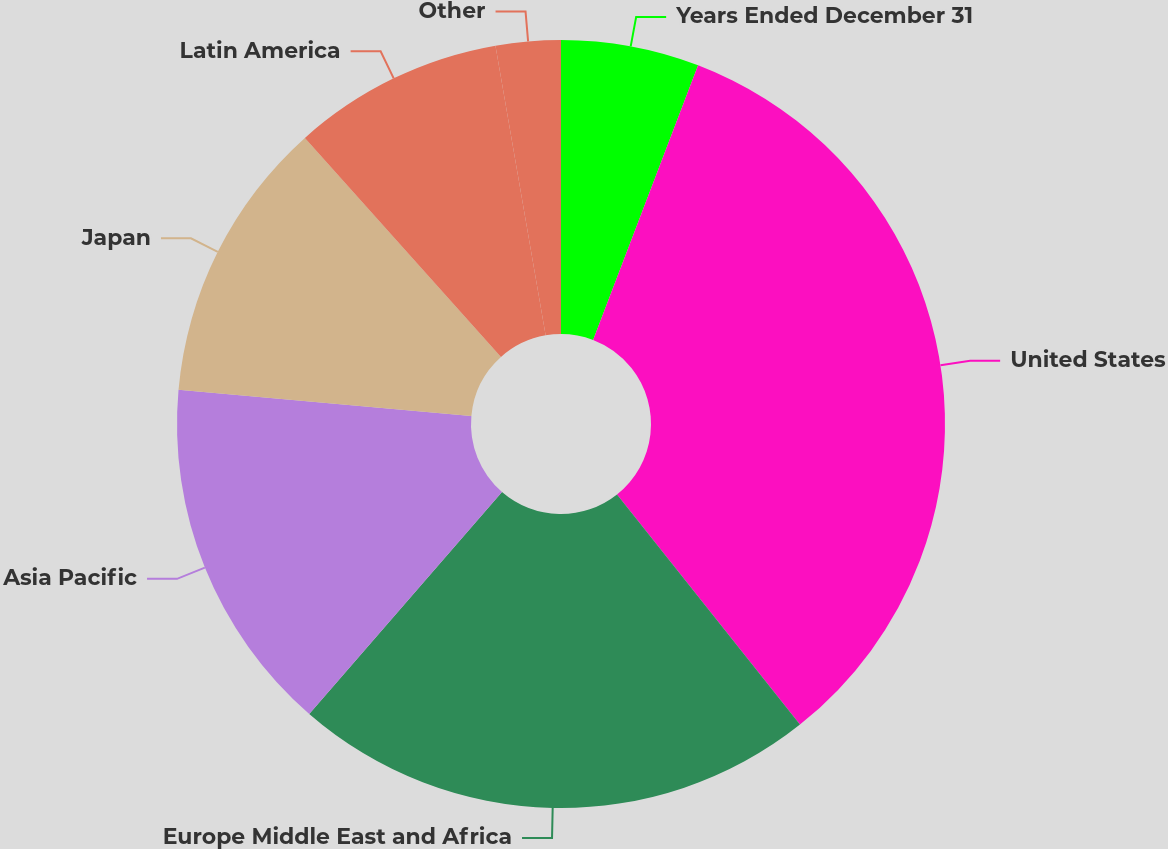Convert chart to OTSL. <chart><loc_0><loc_0><loc_500><loc_500><pie_chart><fcel>Years Ended December 31<fcel>United States<fcel>Europe Middle East and Africa<fcel>Asia Pacific<fcel>Japan<fcel>Latin America<fcel>Other<nl><fcel>5.81%<fcel>33.5%<fcel>22.07%<fcel>15.04%<fcel>11.96%<fcel>8.89%<fcel>2.73%<nl></chart> 